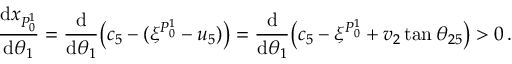<formula> <loc_0><loc_0><loc_500><loc_500>\frac { d x _ { P _ { 0 } ^ { 1 } } } { d \theta _ { 1 } } = \frac { d } { d \theta _ { 1 } } \left ( c _ { 5 } - ( \xi ^ { P _ { 0 } ^ { 1 } } - u _ { 5 } ) \right ) = \frac { d } { d \theta _ { 1 } } \left ( c _ { 5 } - \xi ^ { P _ { 0 } ^ { 1 } } + v _ { 2 } \tan \theta _ { 2 5 } \right ) > 0 \, .</formula> 